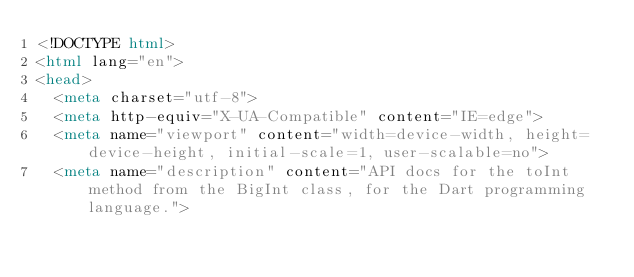Convert code to text. <code><loc_0><loc_0><loc_500><loc_500><_HTML_><!DOCTYPE html>
<html lang="en">
<head>
  <meta charset="utf-8">
  <meta http-equiv="X-UA-Compatible" content="IE=edge">
  <meta name="viewport" content="width=device-width, height=device-height, initial-scale=1, user-scalable=no">
  <meta name="description" content="API docs for the toInt method from the BigInt class, for the Dart programming language."></code> 